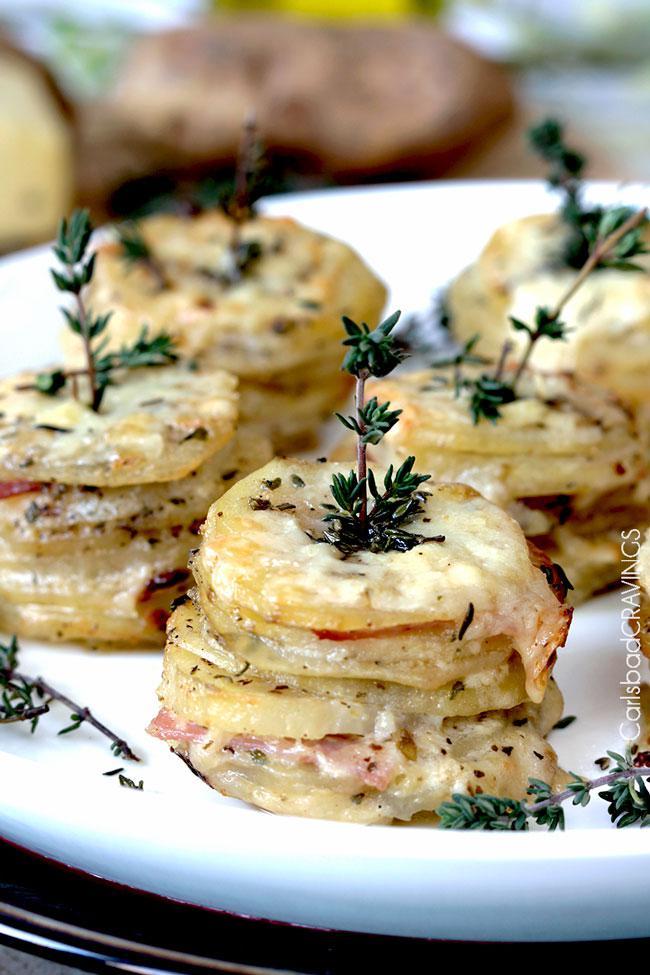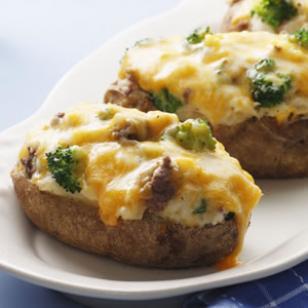The first image is the image on the left, the second image is the image on the right. Analyze the images presented: Is the assertion "One image shows stacked disk shapes garnished with green sprigs, and the other image features something creamy with broccoli florets in it." valid? Answer yes or no. Yes. The first image is the image on the left, the second image is the image on the right. For the images displayed, is the sentence "At least one of the items is topped with a white sauce." factually correct? Answer yes or no. No. 